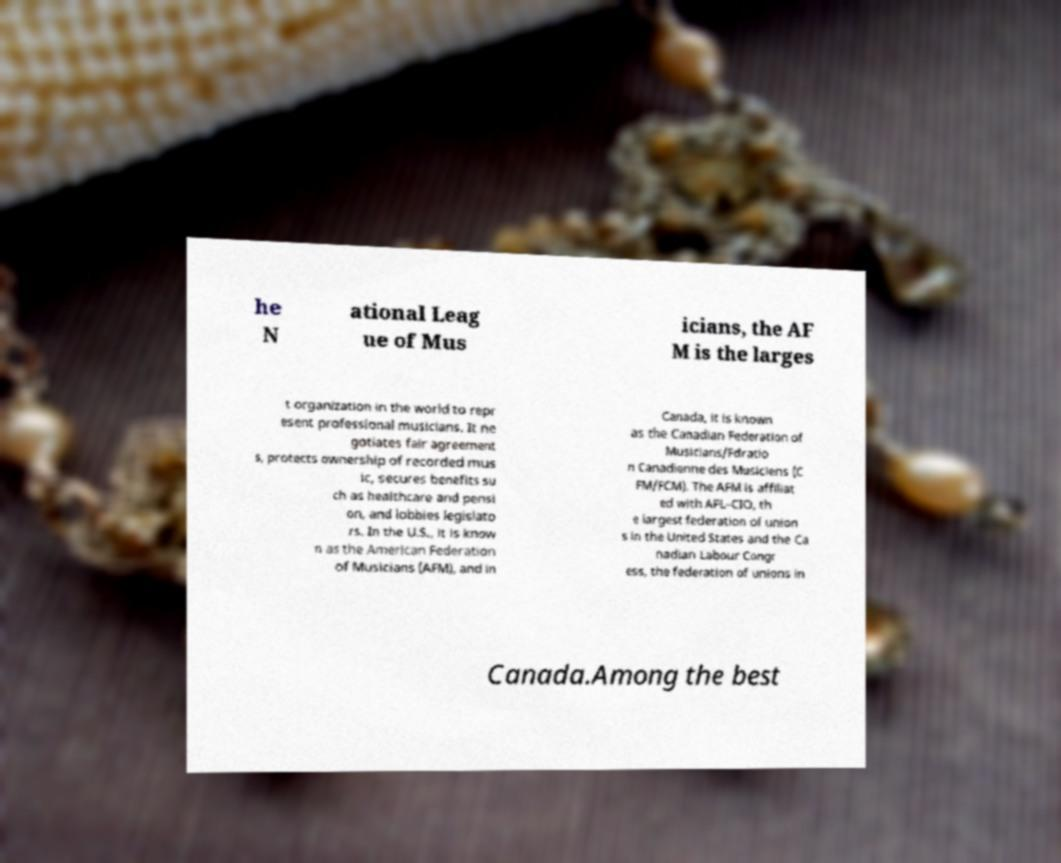There's text embedded in this image that I need extracted. Can you transcribe it verbatim? he N ational Leag ue of Mus icians, the AF M is the larges t organization in the world to repr esent professional musicians. It ne gotiates fair agreement s, protects ownership of recorded mus ic, secures benefits su ch as healthcare and pensi on, and lobbies legislato rs. In the U.S., it is know n as the American Federation of Musicians (AFM), and in Canada, it is known as the Canadian Federation of Musicians/Fdratio n Canadienne des Musiciens (C FM/FCM). The AFM is affiliat ed with AFL–CIO, th e largest federation of union s in the United States and the Ca nadian Labour Congr ess, the federation of unions in Canada.Among the best 